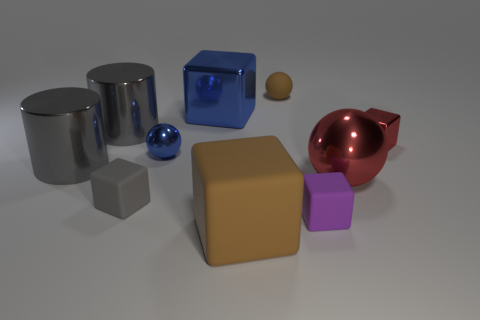What is the color of the big metallic cylinder that is in front of the tiny shiny thing that is to the left of the large blue cube? The color of the larger metallic cylinder positioned in front of the small reflective object, which is to the left of the substantial blue cube, is silver with a reflective surface that mirrors its surroundings. 